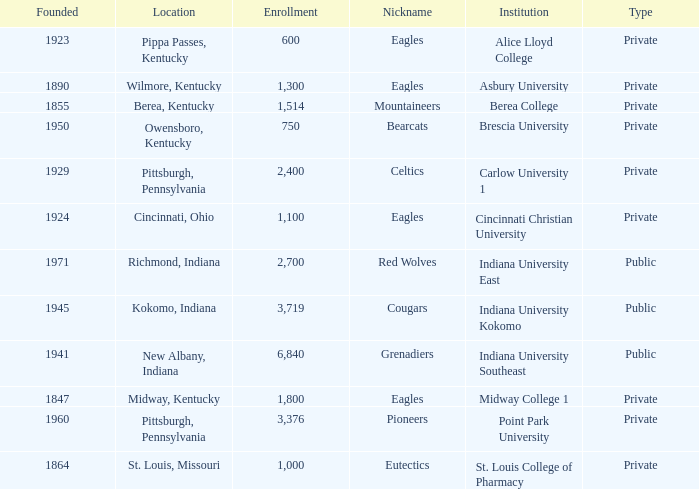Which of the private colleges is the oldest, and whose nickname is the Mountaineers? 1855.0. 